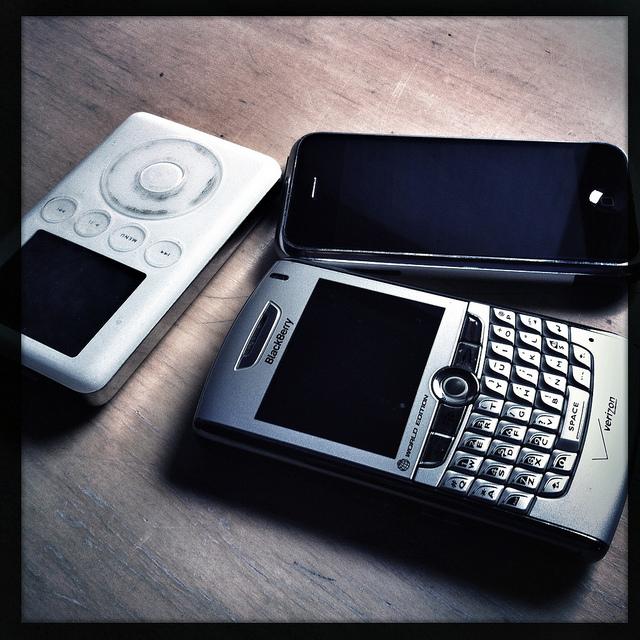What kind of phone is the one on the lower right?
Be succinct. Blackberry. Are these electronics all smartphones?
Give a very brief answer. No. How many phones are these?
Concise answer only. 2. Are these all electronic devices?
Give a very brief answer. Yes. Is this a phone?
Write a very short answer. Yes. What object is next to the cell phone?
Be succinct. Ipod. 